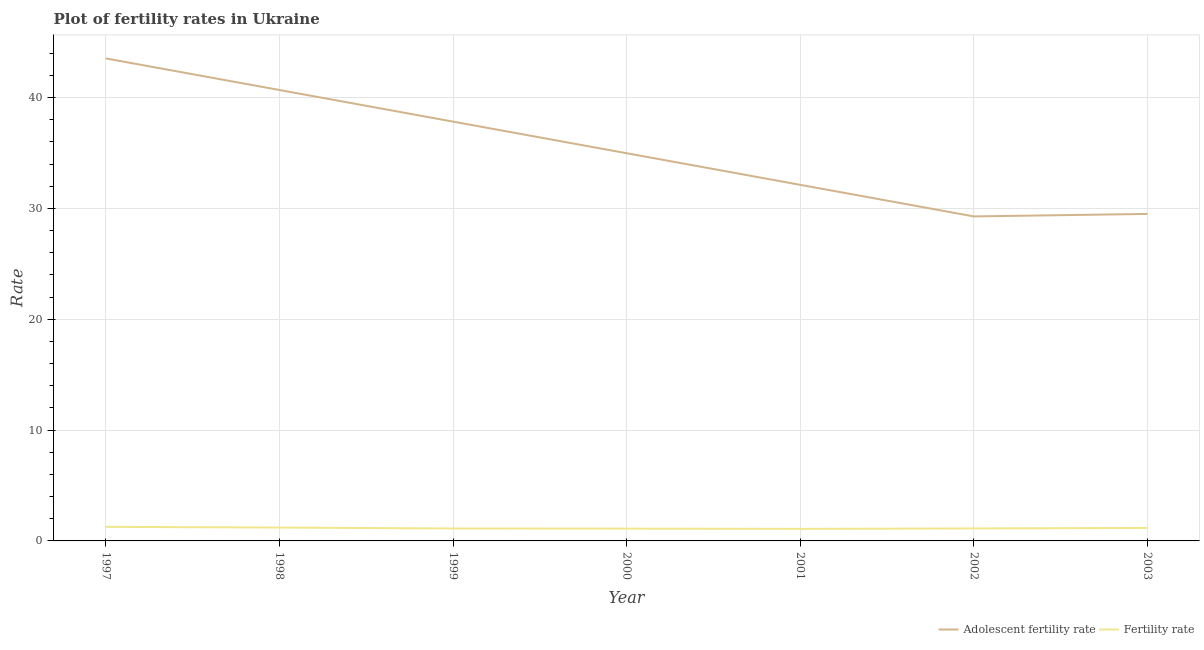Is the number of lines equal to the number of legend labels?
Provide a short and direct response. Yes. What is the adolescent fertility rate in 2003?
Your answer should be compact. 29.51. Across all years, what is the maximum fertility rate?
Offer a terse response. 1.27. Across all years, what is the minimum fertility rate?
Give a very brief answer. 1.08. In which year was the fertility rate maximum?
Ensure brevity in your answer.  1997. In which year was the adolescent fertility rate minimum?
Make the answer very short. 2002. What is the total adolescent fertility rate in the graph?
Provide a short and direct response. 247.96. What is the difference between the adolescent fertility rate in 2000 and that in 2003?
Offer a terse response. 5.48. What is the difference between the fertility rate in 2000 and the adolescent fertility rate in 2001?
Offer a very short reply. -31.02. What is the average adolescent fertility rate per year?
Your answer should be very brief. 35.42. In the year 2002, what is the difference between the adolescent fertility rate and fertility rate?
Your answer should be compact. 28.15. What is the ratio of the adolescent fertility rate in 1997 to that in 2001?
Provide a short and direct response. 1.36. What is the difference between the highest and the second highest fertility rate?
Your response must be concise. 0.06. What is the difference between the highest and the lowest fertility rate?
Offer a terse response. 0.19. In how many years, is the adolescent fertility rate greater than the average adolescent fertility rate taken over all years?
Ensure brevity in your answer.  3. Is the sum of the adolescent fertility rate in 1997 and 2003 greater than the maximum fertility rate across all years?
Your answer should be very brief. Yes. Is the fertility rate strictly greater than the adolescent fertility rate over the years?
Provide a succinct answer. No. What is the difference between two consecutive major ticks on the Y-axis?
Give a very brief answer. 10. Are the values on the major ticks of Y-axis written in scientific E-notation?
Give a very brief answer. No. Does the graph contain any zero values?
Your response must be concise. No. Does the graph contain grids?
Provide a succinct answer. Yes. Where does the legend appear in the graph?
Ensure brevity in your answer.  Bottom right. How many legend labels are there?
Give a very brief answer. 2. How are the legend labels stacked?
Offer a very short reply. Horizontal. What is the title of the graph?
Your answer should be compact. Plot of fertility rates in Ukraine. What is the label or title of the X-axis?
Provide a succinct answer. Year. What is the label or title of the Y-axis?
Your answer should be compact. Rate. What is the Rate of Adolescent fertility rate in 1997?
Make the answer very short. 43.54. What is the Rate in Fertility rate in 1997?
Ensure brevity in your answer.  1.27. What is the Rate in Adolescent fertility rate in 1998?
Offer a very short reply. 40.69. What is the Rate of Fertility rate in 1998?
Keep it short and to the point. 1.21. What is the Rate in Adolescent fertility rate in 1999?
Make the answer very short. 37.83. What is the Rate of Fertility rate in 1999?
Offer a terse response. 1.12. What is the Rate of Adolescent fertility rate in 2000?
Provide a short and direct response. 34.98. What is the Rate of Fertility rate in 2000?
Offer a terse response. 1.11. What is the Rate in Adolescent fertility rate in 2001?
Offer a terse response. 32.13. What is the Rate in Fertility rate in 2001?
Your answer should be compact. 1.08. What is the Rate of Adolescent fertility rate in 2002?
Give a very brief answer. 29.28. What is the Rate in Fertility rate in 2002?
Provide a succinct answer. 1.13. What is the Rate of Adolescent fertility rate in 2003?
Provide a short and direct response. 29.51. What is the Rate in Fertility rate in 2003?
Make the answer very short. 1.17. Across all years, what is the maximum Rate in Adolescent fertility rate?
Your answer should be very brief. 43.54. Across all years, what is the maximum Rate in Fertility rate?
Your answer should be very brief. 1.27. Across all years, what is the minimum Rate of Adolescent fertility rate?
Ensure brevity in your answer.  29.28. Across all years, what is the minimum Rate in Fertility rate?
Ensure brevity in your answer.  1.08. What is the total Rate of Adolescent fertility rate in the graph?
Offer a terse response. 247.96. What is the total Rate in Fertility rate in the graph?
Offer a very short reply. 8.09. What is the difference between the Rate in Adolescent fertility rate in 1997 and that in 1998?
Provide a short and direct response. 2.85. What is the difference between the Rate in Fertility rate in 1997 and that in 1998?
Ensure brevity in your answer.  0.06. What is the difference between the Rate in Adolescent fertility rate in 1997 and that in 1999?
Make the answer very short. 5.7. What is the difference between the Rate of Fertility rate in 1997 and that in 1999?
Offer a very short reply. 0.15. What is the difference between the Rate of Adolescent fertility rate in 1997 and that in 2000?
Provide a short and direct response. 8.56. What is the difference between the Rate in Fertility rate in 1997 and that in 2000?
Provide a short and direct response. 0.16. What is the difference between the Rate in Adolescent fertility rate in 1997 and that in 2001?
Your answer should be compact. 11.41. What is the difference between the Rate of Fertility rate in 1997 and that in 2001?
Your response must be concise. 0.18. What is the difference between the Rate of Adolescent fertility rate in 1997 and that in 2002?
Provide a short and direct response. 14.26. What is the difference between the Rate of Fertility rate in 1997 and that in 2002?
Your answer should be very brief. 0.14. What is the difference between the Rate in Adolescent fertility rate in 1997 and that in 2003?
Your answer should be very brief. 14.03. What is the difference between the Rate of Fertility rate in 1997 and that in 2003?
Provide a short and direct response. 0.1. What is the difference between the Rate of Adolescent fertility rate in 1998 and that in 1999?
Keep it short and to the point. 2.85. What is the difference between the Rate of Fertility rate in 1998 and that in 1999?
Offer a terse response. 0.09. What is the difference between the Rate in Adolescent fertility rate in 1998 and that in 2000?
Provide a succinct answer. 5.7. What is the difference between the Rate of Fertility rate in 1998 and that in 2000?
Provide a succinct answer. 0.1. What is the difference between the Rate in Adolescent fertility rate in 1998 and that in 2001?
Offer a very short reply. 8.56. What is the difference between the Rate of Fertility rate in 1998 and that in 2001?
Ensure brevity in your answer.  0.12. What is the difference between the Rate of Adolescent fertility rate in 1998 and that in 2002?
Your answer should be compact. 11.41. What is the difference between the Rate of Fertility rate in 1998 and that in 2002?
Give a very brief answer. 0.08. What is the difference between the Rate of Adolescent fertility rate in 1998 and that in 2003?
Provide a succinct answer. 11.18. What is the difference between the Rate of Fertility rate in 1998 and that in 2003?
Offer a terse response. 0.04. What is the difference between the Rate in Adolescent fertility rate in 1999 and that in 2000?
Offer a very short reply. 2.85. What is the difference between the Rate of Fertility rate in 1999 and that in 2000?
Provide a short and direct response. 0.01. What is the difference between the Rate of Adolescent fertility rate in 1999 and that in 2001?
Your answer should be compact. 5.7. What is the difference between the Rate of Fertility rate in 1999 and that in 2001?
Your response must be concise. 0.04. What is the difference between the Rate of Adolescent fertility rate in 1999 and that in 2002?
Provide a short and direct response. 8.56. What is the difference between the Rate in Fertility rate in 1999 and that in 2002?
Offer a very short reply. -0.01. What is the difference between the Rate of Adolescent fertility rate in 1999 and that in 2003?
Your response must be concise. 8.33. What is the difference between the Rate in Fertility rate in 1999 and that in 2003?
Your answer should be very brief. -0.05. What is the difference between the Rate in Adolescent fertility rate in 2000 and that in 2001?
Your answer should be compact. 2.85. What is the difference between the Rate of Fertility rate in 2000 and that in 2001?
Your answer should be very brief. 0.03. What is the difference between the Rate in Adolescent fertility rate in 2000 and that in 2002?
Provide a short and direct response. 5.7. What is the difference between the Rate in Fertility rate in 2000 and that in 2002?
Your answer should be compact. -0.02. What is the difference between the Rate in Adolescent fertility rate in 2000 and that in 2003?
Give a very brief answer. 5.48. What is the difference between the Rate of Fertility rate in 2000 and that in 2003?
Your answer should be compact. -0.06. What is the difference between the Rate of Adolescent fertility rate in 2001 and that in 2002?
Offer a terse response. 2.85. What is the difference between the Rate of Fertility rate in 2001 and that in 2002?
Ensure brevity in your answer.  -0.04. What is the difference between the Rate in Adolescent fertility rate in 2001 and that in 2003?
Your answer should be compact. 2.63. What is the difference between the Rate in Fertility rate in 2001 and that in 2003?
Make the answer very short. -0.09. What is the difference between the Rate of Adolescent fertility rate in 2002 and that in 2003?
Make the answer very short. -0.23. What is the difference between the Rate of Fertility rate in 2002 and that in 2003?
Your answer should be compact. -0.05. What is the difference between the Rate in Adolescent fertility rate in 1997 and the Rate in Fertility rate in 1998?
Ensure brevity in your answer.  42.33. What is the difference between the Rate in Adolescent fertility rate in 1997 and the Rate in Fertility rate in 1999?
Keep it short and to the point. 42.42. What is the difference between the Rate in Adolescent fertility rate in 1997 and the Rate in Fertility rate in 2000?
Provide a succinct answer. 42.43. What is the difference between the Rate in Adolescent fertility rate in 1997 and the Rate in Fertility rate in 2001?
Your response must be concise. 42.45. What is the difference between the Rate of Adolescent fertility rate in 1997 and the Rate of Fertility rate in 2002?
Provide a succinct answer. 42.41. What is the difference between the Rate in Adolescent fertility rate in 1997 and the Rate in Fertility rate in 2003?
Ensure brevity in your answer.  42.37. What is the difference between the Rate in Adolescent fertility rate in 1998 and the Rate in Fertility rate in 1999?
Make the answer very short. 39.57. What is the difference between the Rate in Adolescent fertility rate in 1998 and the Rate in Fertility rate in 2000?
Give a very brief answer. 39.58. What is the difference between the Rate in Adolescent fertility rate in 1998 and the Rate in Fertility rate in 2001?
Provide a succinct answer. 39.6. What is the difference between the Rate in Adolescent fertility rate in 1998 and the Rate in Fertility rate in 2002?
Provide a short and direct response. 39.56. What is the difference between the Rate of Adolescent fertility rate in 1998 and the Rate of Fertility rate in 2003?
Offer a terse response. 39.51. What is the difference between the Rate of Adolescent fertility rate in 1999 and the Rate of Fertility rate in 2000?
Your response must be concise. 36.72. What is the difference between the Rate of Adolescent fertility rate in 1999 and the Rate of Fertility rate in 2001?
Make the answer very short. 36.75. What is the difference between the Rate in Adolescent fertility rate in 1999 and the Rate in Fertility rate in 2002?
Provide a succinct answer. 36.71. What is the difference between the Rate in Adolescent fertility rate in 1999 and the Rate in Fertility rate in 2003?
Give a very brief answer. 36.66. What is the difference between the Rate of Adolescent fertility rate in 2000 and the Rate of Fertility rate in 2001?
Give a very brief answer. 33.9. What is the difference between the Rate of Adolescent fertility rate in 2000 and the Rate of Fertility rate in 2002?
Provide a short and direct response. 33.86. What is the difference between the Rate in Adolescent fertility rate in 2000 and the Rate in Fertility rate in 2003?
Your answer should be very brief. 33.81. What is the difference between the Rate in Adolescent fertility rate in 2001 and the Rate in Fertility rate in 2002?
Your answer should be very brief. 31. What is the difference between the Rate in Adolescent fertility rate in 2001 and the Rate in Fertility rate in 2003?
Offer a very short reply. 30.96. What is the difference between the Rate of Adolescent fertility rate in 2002 and the Rate of Fertility rate in 2003?
Your answer should be very brief. 28.11. What is the average Rate in Adolescent fertility rate per year?
Give a very brief answer. 35.42. What is the average Rate in Fertility rate per year?
Offer a terse response. 1.16. In the year 1997, what is the difference between the Rate of Adolescent fertility rate and Rate of Fertility rate?
Offer a terse response. 42.27. In the year 1998, what is the difference between the Rate in Adolescent fertility rate and Rate in Fertility rate?
Give a very brief answer. 39.48. In the year 1999, what is the difference between the Rate of Adolescent fertility rate and Rate of Fertility rate?
Your response must be concise. 36.71. In the year 2000, what is the difference between the Rate of Adolescent fertility rate and Rate of Fertility rate?
Offer a very short reply. 33.87. In the year 2001, what is the difference between the Rate in Adolescent fertility rate and Rate in Fertility rate?
Give a very brief answer. 31.05. In the year 2002, what is the difference between the Rate of Adolescent fertility rate and Rate of Fertility rate?
Your answer should be compact. 28.15. In the year 2003, what is the difference between the Rate of Adolescent fertility rate and Rate of Fertility rate?
Your response must be concise. 28.33. What is the ratio of the Rate in Adolescent fertility rate in 1997 to that in 1998?
Offer a very short reply. 1.07. What is the ratio of the Rate in Fertility rate in 1997 to that in 1998?
Your answer should be very brief. 1.05. What is the ratio of the Rate of Adolescent fertility rate in 1997 to that in 1999?
Your answer should be very brief. 1.15. What is the ratio of the Rate of Fertility rate in 1997 to that in 1999?
Keep it short and to the point. 1.13. What is the ratio of the Rate in Adolescent fertility rate in 1997 to that in 2000?
Offer a very short reply. 1.24. What is the ratio of the Rate of Fertility rate in 1997 to that in 2000?
Your answer should be compact. 1.14. What is the ratio of the Rate in Adolescent fertility rate in 1997 to that in 2001?
Your answer should be very brief. 1.35. What is the ratio of the Rate in Fertility rate in 1997 to that in 2001?
Your response must be concise. 1.17. What is the ratio of the Rate in Adolescent fertility rate in 1997 to that in 2002?
Provide a short and direct response. 1.49. What is the ratio of the Rate in Fertility rate in 1997 to that in 2002?
Offer a terse response. 1.13. What is the ratio of the Rate in Adolescent fertility rate in 1997 to that in 2003?
Provide a succinct answer. 1.48. What is the ratio of the Rate of Fertility rate in 1997 to that in 2003?
Your response must be concise. 1.08. What is the ratio of the Rate of Adolescent fertility rate in 1998 to that in 1999?
Offer a terse response. 1.08. What is the ratio of the Rate of Fertility rate in 1998 to that in 1999?
Give a very brief answer. 1.08. What is the ratio of the Rate of Adolescent fertility rate in 1998 to that in 2000?
Give a very brief answer. 1.16. What is the ratio of the Rate of Fertility rate in 1998 to that in 2000?
Make the answer very short. 1.09. What is the ratio of the Rate in Adolescent fertility rate in 1998 to that in 2001?
Ensure brevity in your answer.  1.27. What is the ratio of the Rate of Fertility rate in 1998 to that in 2001?
Offer a very short reply. 1.11. What is the ratio of the Rate in Adolescent fertility rate in 1998 to that in 2002?
Make the answer very short. 1.39. What is the ratio of the Rate in Fertility rate in 1998 to that in 2002?
Your response must be concise. 1.07. What is the ratio of the Rate in Adolescent fertility rate in 1998 to that in 2003?
Make the answer very short. 1.38. What is the ratio of the Rate of Fertility rate in 1998 to that in 2003?
Make the answer very short. 1.03. What is the ratio of the Rate in Adolescent fertility rate in 1999 to that in 2000?
Provide a short and direct response. 1.08. What is the ratio of the Rate in Fertility rate in 1999 to that in 2000?
Provide a succinct answer. 1.01. What is the ratio of the Rate in Adolescent fertility rate in 1999 to that in 2001?
Give a very brief answer. 1.18. What is the ratio of the Rate in Fertility rate in 1999 to that in 2001?
Your answer should be very brief. 1.03. What is the ratio of the Rate of Adolescent fertility rate in 1999 to that in 2002?
Your answer should be compact. 1.29. What is the ratio of the Rate in Adolescent fertility rate in 1999 to that in 2003?
Your answer should be compact. 1.28. What is the ratio of the Rate of Fertility rate in 1999 to that in 2003?
Make the answer very short. 0.96. What is the ratio of the Rate of Adolescent fertility rate in 2000 to that in 2001?
Give a very brief answer. 1.09. What is the ratio of the Rate in Fertility rate in 2000 to that in 2001?
Offer a terse response. 1.02. What is the ratio of the Rate in Adolescent fertility rate in 2000 to that in 2002?
Provide a short and direct response. 1.19. What is the ratio of the Rate of Fertility rate in 2000 to that in 2002?
Ensure brevity in your answer.  0.99. What is the ratio of the Rate of Adolescent fertility rate in 2000 to that in 2003?
Your answer should be very brief. 1.19. What is the ratio of the Rate in Fertility rate in 2000 to that in 2003?
Give a very brief answer. 0.95. What is the ratio of the Rate in Adolescent fertility rate in 2001 to that in 2002?
Give a very brief answer. 1.1. What is the ratio of the Rate in Fertility rate in 2001 to that in 2002?
Keep it short and to the point. 0.96. What is the ratio of the Rate of Adolescent fertility rate in 2001 to that in 2003?
Your response must be concise. 1.09. What is the ratio of the Rate in Fertility rate in 2001 to that in 2003?
Provide a short and direct response. 0.93. What is the ratio of the Rate of Fertility rate in 2002 to that in 2003?
Your answer should be compact. 0.96. What is the difference between the highest and the second highest Rate of Adolescent fertility rate?
Offer a terse response. 2.85. What is the difference between the highest and the second highest Rate of Fertility rate?
Your response must be concise. 0.06. What is the difference between the highest and the lowest Rate in Adolescent fertility rate?
Your answer should be very brief. 14.26. What is the difference between the highest and the lowest Rate in Fertility rate?
Give a very brief answer. 0.18. 